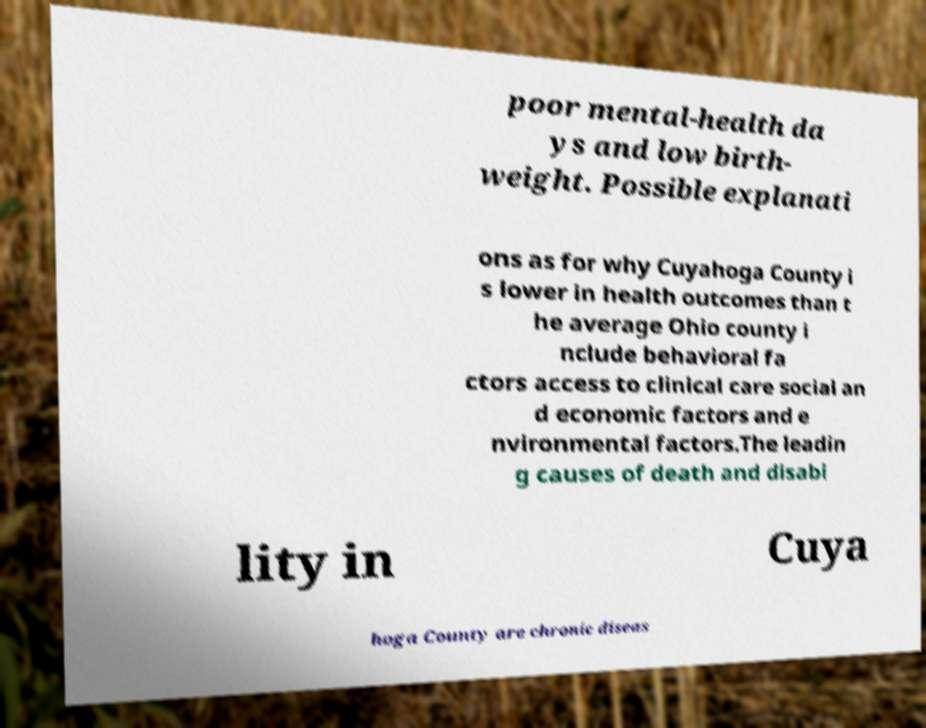Can you accurately transcribe the text from the provided image for me? poor mental-health da ys and low birth- weight. Possible explanati ons as for why Cuyahoga County i s lower in health outcomes than t he average Ohio county i nclude behavioral fa ctors access to clinical care social an d economic factors and e nvironmental factors.The leadin g causes of death and disabi lity in Cuya hoga County are chronic diseas 